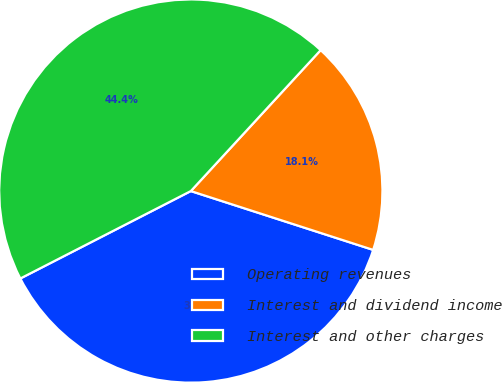Convert chart. <chart><loc_0><loc_0><loc_500><loc_500><pie_chart><fcel>Operating revenues<fcel>Interest and dividend income<fcel>Interest and other charges<nl><fcel>37.49%<fcel>18.12%<fcel>44.39%<nl></chart> 